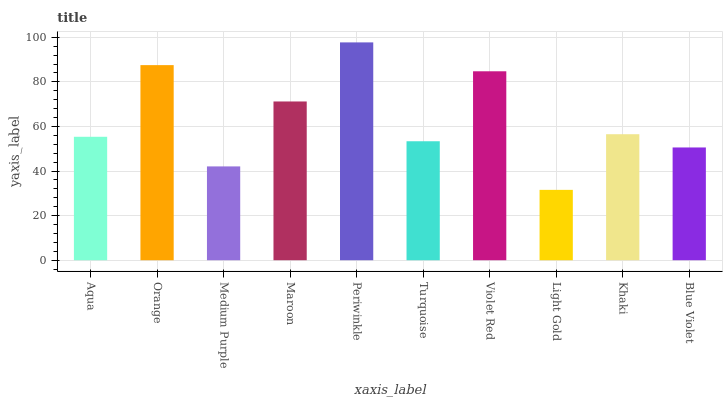Is Light Gold the minimum?
Answer yes or no. Yes. Is Periwinkle the maximum?
Answer yes or no. Yes. Is Orange the minimum?
Answer yes or no. No. Is Orange the maximum?
Answer yes or no. No. Is Orange greater than Aqua?
Answer yes or no. Yes. Is Aqua less than Orange?
Answer yes or no. Yes. Is Aqua greater than Orange?
Answer yes or no. No. Is Orange less than Aqua?
Answer yes or no. No. Is Khaki the high median?
Answer yes or no. Yes. Is Aqua the low median?
Answer yes or no. Yes. Is Turquoise the high median?
Answer yes or no. No. Is Light Gold the low median?
Answer yes or no. No. 